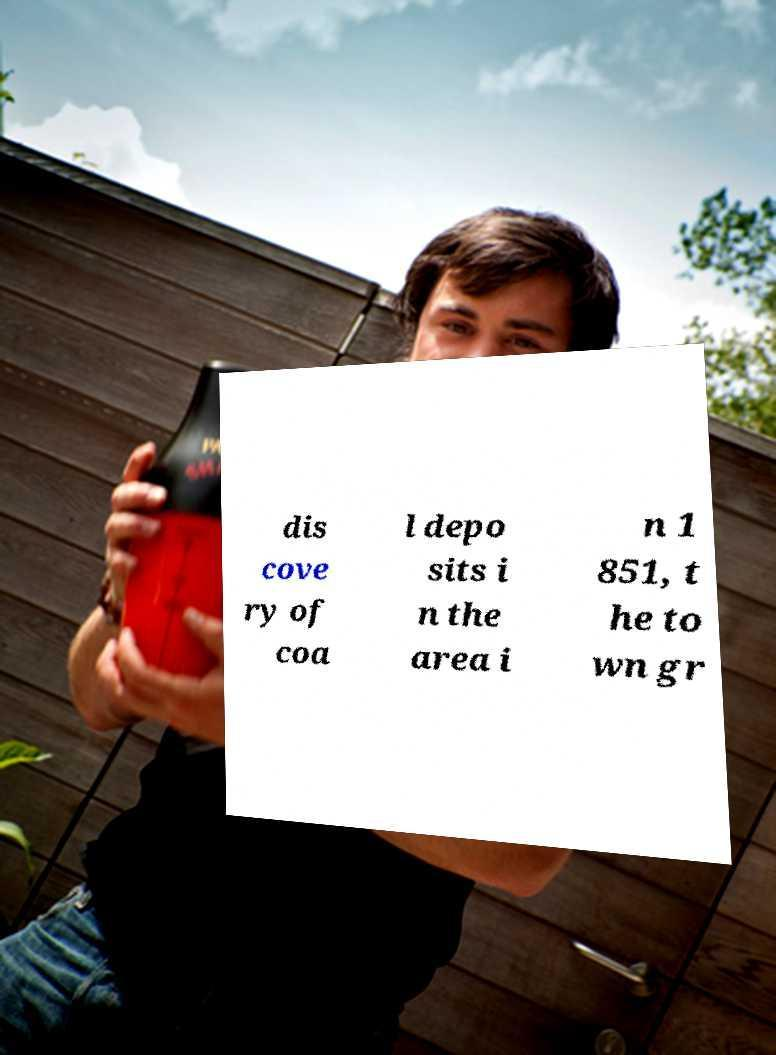For documentation purposes, I need the text within this image transcribed. Could you provide that? dis cove ry of coa l depo sits i n the area i n 1 851, t he to wn gr 